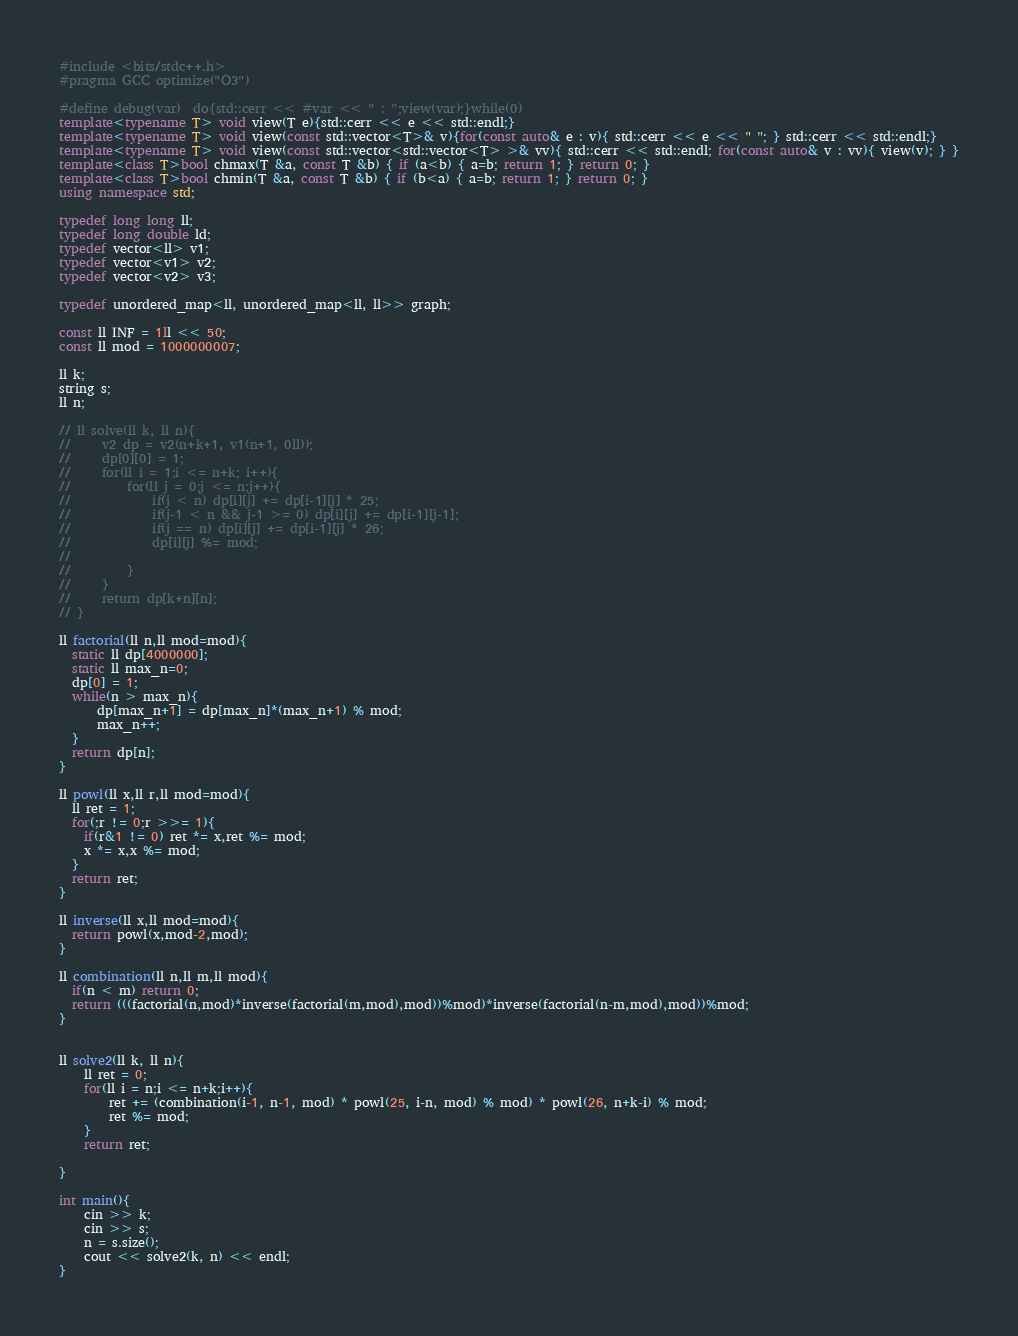Convert code to text. <code><loc_0><loc_0><loc_500><loc_500><_C++_>#include <bits/stdc++.h>
#pragma GCC optimize("O3")

#define debug(var)  do{std::cerr << #var << " : ";view(var);}while(0)
template<typename T> void view(T e){std::cerr << e << std::endl;}
template<typename T> void view(const std::vector<T>& v){for(const auto& e : v){ std::cerr << e << " "; } std::cerr << std::endl;}
template<typename T> void view(const std::vector<std::vector<T> >& vv){ std::cerr << std::endl; for(const auto& v : vv){ view(v); } }
template<class T>bool chmax(T &a, const T &b) { if (a<b) { a=b; return 1; } return 0; }
template<class T>bool chmin(T &a, const T &b) { if (b<a) { a=b; return 1; } return 0; }
using namespace std;

typedef long long ll;
typedef long double ld;
typedef vector<ll> v1;
typedef vector<v1> v2;
typedef vector<v2> v3;

typedef unordered_map<ll, unordered_map<ll, ll>> graph;

const ll INF = 1ll << 50;
const ll mod = 1000000007;

ll k;
string s;
ll n;

// ll solve(ll k, ll n){
//     v2 dp = v2(n+k+1, v1(n+1, 0ll));
//     dp[0][0] = 1;
//     for(ll i = 1;i <= n+k; i++){
//         for(ll j = 0;j <= n;j++){
//             if(j < n) dp[i][j] += dp[i-1][j] * 25;
//             if(j-1 < n && j-1 >= 0) dp[i][j] += dp[i-1][j-1];
//             if(j == n) dp[i][j] += dp[i-1][j] * 26;
//             dp[i][j] %= mod;
//
//         }
//     }
//     return dp[k+n][n];
// }

ll factorial(ll n,ll mod=mod){
  static ll dp[4000000];
  static ll max_n=0;
  dp[0] = 1;
  while(n > max_n){
      dp[max_n+1] = dp[max_n]*(max_n+1) % mod;
      max_n++;
  }
  return dp[n];
}

ll powl(ll x,ll r,ll mod=mod){
  ll ret = 1;
  for(;r != 0;r >>= 1){
    if(r&1 != 0) ret *= x,ret %= mod;
    x *= x,x %= mod;
  }
  return ret;
}

ll inverse(ll x,ll mod=mod){
  return powl(x,mod-2,mod);
}

ll combination(ll n,ll m,ll mod){
  if(n < m) return 0;
  return (((factorial(n,mod)*inverse(factorial(m,mod),mod))%mod)*inverse(factorial(n-m,mod),mod))%mod;
}


ll solve2(ll k, ll n){
    ll ret = 0;
    for(ll i = n;i <= n+k;i++){
        ret += (combination(i-1, n-1, mod) * powl(25, i-n, mod) % mod) * powl(26, n+k-i) % mod;
        ret %= mod;
    }
    return ret;

}

int main(){
    cin >> k;
    cin >> s;
    n = s.size();
    cout << solve2(k, n) << endl;
}
</code> 